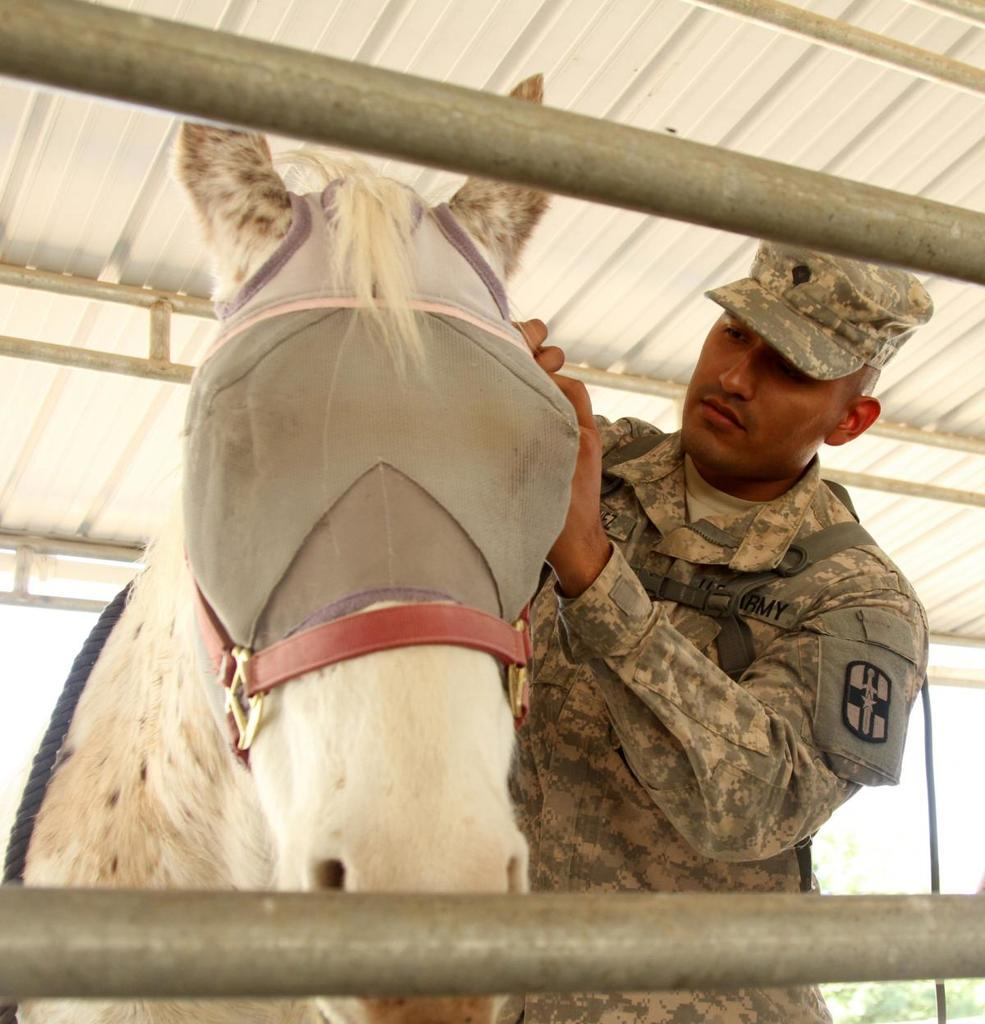What type of animal is in the image? There is a white-colored horse in the image. Who is with the horse in the image? A man is standing beside the horse. What is the man doing with the horse? The man has his hands on the horse. What structure can be seen at the top of the image? There is a roof shed visible at the top of the image. What type of nut is being used to support the horse in the image? There is no nut present in the image, and the horse is not being supported by any object. 